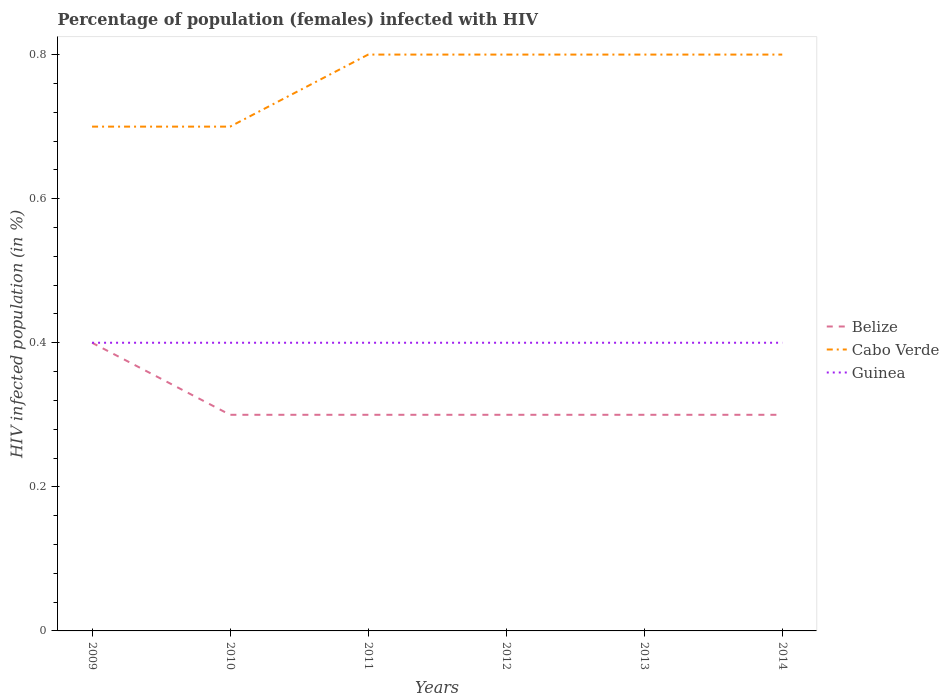Does the line corresponding to Cabo Verde intersect with the line corresponding to Guinea?
Provide a succinct answer. No. Across all years, what is the maximum percentage of HIV infected female population in Guinea?
Offer a terse response. 0.4. In which year was the percentage of HIV infected female population in Cabo Verde maximum?
Offer a very short reply. 2009. What is the difference between the highest and the lowest percentage of HIV infected female population in Guinea?
Provide a short and direct response. 6. What is the difference between two consecutive major ticks on the Y-axis?
Make the answer very short. 0.2. Does the graph contain any zero values?
Provide a short and direct response. No. Where does the legend appear in the graph?
Ensure brevity in your answer.  Center right. How many legend labels are there?
Provide a short and direct response. 3. What is the title of the graph?
Provide a succinct answer. Percentage of population (females) infected with HIV. Does "Benin" appear as one of the legend labels in the graph?
Offer a terse response. No. What is the label or title of the Y-axis?
Make the answer very short. HIV infected population (in %). What is the HIV infected population (in %) of Cabo Verde in 2009?
Give a very brief answer. 0.7. What is the HIV infected population (in %) of Guinea in 2009?
Provide a succinct answer. 0.4. What is the HIV infected population (in %) in Belize in 2010?
Make the answer very short. 0.3. What is the HIV infected population (in %) in Guinea in 2010?
Make the answer very short. 0.4. What is the HIV infected population (in %) in Cabo Verde in 2011?
Provide a short and direct response. 0.8. What is the HIV infected population (in %) of Guinea in 2011?
Offer a very short reply. 0.4. What is the HIV infected population (in %) of Guinea in 2012?
Provide a short and direct response. 0.4. What is the HIV infected population (in %) in Belize in 2013?
Provide a succinct answer. 0.3. What is the HIV infected population (in %) in Cabo Verde in 2013?
Keep it short and to the point. 0.8. Across all years, what is the maximum HIV infected population (in %) of Belize?
Your answer should be compact. 0.4. Across all years, what is the maximum HIV infected population (in %) in Guinea?
Provide a short and direct response. 0.4. Across all years, what is the minimum HIV infected population (in %) of Cabo Verde?
Your response must be concise. 0.7. What is the total HIV infected population (in %) of Belize in the graph?
Offer a terse response. 1.9. What is the total HIV infected population (in %) of Cabo Verde in the graph?
Your response must be concise. 4.6. What is the total HIV infected population (in %) of Guinea in the graph?
Your answer should be very brief. 2.4. What is the difference between the HIV infected population (in %) of Belize in 2009 and that in 2010?
Keep it short and to the point. 0.1. What is the difference between the HIV infected population (in %) of Belize in 2009 and that in 2011?
Your response must be concise. 0.1. What is the difference between the HIV infected population (in %) in Cabo Verde in 2009 and that in 2011?
Give a very brief answer. -0.1. What is the difference between the HIV infected population (in %) of Belize in 2009 and that in 2012?
Offer a terse response. 0.1. What is the difference between the HIV infected population (in %) in Cabo Verde in 2009 and that in 2012?
Provide a succinct answer. -0.1. What is the difference between the HIV infected population (in %) of Guinea in 2009 and that in 2012?
Your answer should be very brief. 0. What is the difference between the HIV infected population (in %) of Cabo Verde in 2009 and that in 2013?
Provide a succinct answer. -0.1. What is the difference between the HIV infected population (in %) of Cabo Verde in 2009 and that in 2014?
Your answer should be very brief. -0.1. What is the difference between the HIV infected population (in %) in Guinea in 2009 and that in 2014?
Offer a very short reply. 0. What is the difference between the HIV infected population (in %) in Cabo Verde in 2010 and that in 2011?
Provide a short and direct response. -0.1. What is the difference between the HIV infected population (in %) in Guinea in 2010 and that in 2011?
Ensure brevity in your answer.  0. What is the difference between the HIV infected population (in %) of Belize in 2010 and that in 2012?
Give a very brief answer. 0. What is the difference between the HIV infected population (in %) in Guinea in 2010 and that in 2012?
Give a very brief answer. 0. What is the difference between the HIV infected population (in %) of Belize in 2010 and that in 2013?
Offer a terse response. 0. What is the difference between the HIV infected population (in %) in Cabo Verde in 2010 and that in 2013?
Offer a very short reply. -0.1. What is the difference between the HIV infected population (in %) of Guinea in 2010 and that in 2013?
Your answer should be very brief. 0. What is the difference between the HIV infected population (in %) in Cabo Verde in 2010 and that in 2014?
Keep it short and to the point. -0.1. What is the difference between the HIV infected population (in %) in Guinea in 2010 and that in 2014?
Give a very brief answer. 0. What is the difference between the HIV infected population (in %) in Belize in 2011 and that in 2012?
Ensure brevity in your answer.  0. What is the difference between the HIV infected population (in %) in Cabo Verde in 2011 and that in 2012?
Offer a very short reply. 0. What is the difference between the HIV infected population (in %) in Guinea in 2011 and that in 2012?
Provide a succinct answer. 0. What is the difference between the HIV infected population (in %) of Guinea in 2011 and that in 2013?
Make the answer very short. 0. What is the difference between the HIV infected population (in %) of Belize in 2011 and that in 2014?
Give a very brief answer. 0. What is the difference between the HIV infected population (in %) of Cabo Verde in 2011 and that in 2014?
Provide a succinct answer. 0. What is the difference between the HIV infected population (in %) of Guinea in 2011 and that in 2014?
Offer a terse response. 0. What is the difference between the HIV infected population (in %) of Belize in 2012 and that in 2013?
Your response must be concise. 0. What is the difference between the HIV infected population (in %) in Cabo Verde in 2012 and that in 2013?
Provide a short and direct response. 0. What is the difference between the HIV infected population (in %) in Guinea in 2012 and that in 2013?
Give a very brief answer. 0. What is the difference between the HIV infected population (in %) of Belize in 2012 and that in 2014?
Ensure brevity in your answer.  0. What is the difference between the HIV infected population (in %) in Cabo Verde in 2013 and that in 2014?
Give a very brief answer. 0. What is the difference between the HIV infected population (in %) of Guinea in 2013 and that in 2014?
Provide a succinct answer. 0. What is the difference between the HIV infected population (in %) of Belize in 2009 and the HIV infected population (in %) of Cabo Verde in 2010?
Your answer should be very brief. -0.3. What is the difference between the HIV infected population (in %) in Belize in 2009 and the HIV infected population (in %) in Guinea in 2010?
Your answer should be compact. 0. What is the difference between the HIV infected population (in %) of Cabo Verde in 2009 and the HIV infected population (in %) of Guinea in 2010?
Provide a short and direct response. 0.3. What is the difference between the HIV infected population (in %) of Belize in 2009 and the HIV infected population (in %) of Cabo Verde in 2011?
Your answer should be very brief. -0.4. What is the difference between the HIV infected population (in %) in Cabo Verde in 2009 and the HIV infected population (in %) in Guinea in 2011?
Offer a very short reply. 0.3. What is the difference between the HIV infected population (in %) in Belize in 2009 and the HIV infected population (in %) in Cabo Verde in 2012?
Offer a terse response. -0.4. What is the difference between the HIV infected population (in %) of Cabo Verde in 2009 and the HIV infected population (in %) of Guinea in 2012?
Offer a terse response. 0.3. What is the difference between the HIV infected population (in %) in Belize in 2009 and the HIV infected population (in %) in Cabo Verde in 2013?
Provide a short and direct response. -0.4. What is the difference between the HIV infected population (in %) of Belize in 2009 and the HIV infected population (in %) of Cabo Verde in 2014?
Give a very brief answer. -0.4. What is the difference between the HIV infected population (in %) in Belize in 2009 and the HIV infected population (in %) in Guinea in 2014?
Your response must be concise. 0. What is the difference between the HIV infected population (in %) of Cabo Verde in 2010 and the HIV infected population (in %) of Guinea in 2011?
Give a very brief answer. 0.3. What is the difference between the HIV infected population (in %) in Belize in 2010 and the HIV infected population (in %) in Guinea in 2012?
Make the answer very short. -0.1. What is the difference between the HIV infected population (in %) of Cabo Verde in 2010 and the HIV infected population (in %) of Guinea in 2012?
Your response must be concise. 0.3. What is the difference between the HIV infected population (in %) in Belize in 2010 and the HIV infected population (in %) in Cabo Verde in 2013?
Offer a terse response. -0.5. What is the difference between the HIV infected population (in %) in Belize in 2010 and the HIV infected population (in %) in Guinea in 2013?
Offer a terse response. -0.1. What is the difference between the HIV infected population (in %) of Belize in 2010 and the HIV infected population (in %) of Guinea in 2014?
Ensure brevity in your answer.  -0.1. What is the difference between the HIV infected population (in %) of Belize in 2011 and the HIV infected population (in %) of Guinea in 2012?
Provide a succinct answer. -0.1. What is the difference between the HIV infected population (in %) of Cabo Verde in 2011 and the HIV infected population (in %) of Guinea in 2012?
Your response must be concise. 0.4. What is the difference between the HIV infected population (in %) of Cabo Verde in 2011 and the HIV infected population (in %) of Guinea in 2013?
Your answer should be very brief. 0.4. What is the difference between the HIV infected population (in %) of Belize in 2011 and the HIV infected population (in %) of Guinea in 2014?
Your response must be concise. -0.1. What is the difference between the HIV infected population (in %) in Belize in 2012 and the HIV infected population (in %) in Guinea in 2013?
Provide a succinct answer. -0.1. What is the difference between the HIV infected population (in %) in Belize in 2012 and the HIV infected population (in %) in Guinea in 2014?
Offer a very short reply. -0.1. What is the difference between the HIV infected population (in %) in Cabo Verde in 2012 and the HIV infected population (in %) in Guinea in 2014?
Make the answer very short. 0.4. What is the difference between the HIV infected population (in %) of Cabo Verde in 2013 and the HIV infected population (in %) of Guinea in 2014?
Your answer should be compact. 0.4. What is the average HIV infected population (in %) of Belize per year?
Your response must be concise. 0.32. What is the average HIV infected population (in %) of Cabo Verde per year?
Provide a short and direct response. 0.77. What is the average HIV infected population (in %) in Guinea per year?
Offer a very short reply. 0.4. In the year 2009, what is the difference between the HIV infected population (in %) of Belize and HIV infected population (in %) of Cabo Verde?
Give a very brief answer. -0.3. In the year 2009, what is the difference between the HIV infected population (in %) in Belize and HIV infected population (in %) in Guinea?
Give a very brief answer. 0. In the year 2009, what is the difference between the HIV infected population (in %) of Cabo Verde and HIV infected population (in %) of Guinea?
Your answer should be very brief. 0.3. In the year 2010, what is the difference between the HIV infected population (in %) of Belize and HIV infected population (in %) of Cabo Verde?
Make the answer very short. -0.4. In the year 2011, what is the difference between the HIV infected population (in %) in Belize and HIV infected population (in %) in Cabo Verde?
Provide a succinct answer. -0.5. In the year 2011, what is the difference between the HIV infected population (in %) of Belize and HIV infected population (in %) of Guinea?
Make the answer very short. -0.1. In the year 2012, what is the difference between the HIV infected population (in %) of Belize and HIV infected population (in %) of Guinea?
Keep it short and to the point. -0.1. In the year 2012, what is the difference between the HIV infected population (in %) in Cabo Verde and HIV infected population (in %) in Guinea?
Give a very brief answer. 0.4. In the year 2013, what is the difference between the HIV infected population (in %) in Belize and HIV infected population (in %) in Guinea?
Keep it short and to the point. -0.1. What is the ratio of the HIV infected population (in %) in Belize in 2009 to that in 2010?
Offer a terse response. 1.33. What is the ratio of the HIV infected population (in %) in Guinea in 2009 to that in 2010?
Make the answer very short. 1. What is the ratio of the HIV infected population (in %) in Cabo Verde in 2009 to that in 2011?
Provide a succinct answer. 0.88. What is the ratio of the HIV infected population (in %) of Guinea in 2009 to that in 2011?
Make the answer very short. 1. What is the ratio of the HIV infected population (in %) of Cabo Verde in 2009 to that in 2012?
Give a very brief answer. 0.88. What is the ratio of the HIV infected population (in %) of Belize in 2009 to that in 2013?
Provide a short and direct response. 1.33. What is the ratio of the HIV infected population (in %) of Cabo Verde in 2009 to that in 2013?
Give a very brief answer. 0.88. What is the ratio of the HIV infected population (in %) in Belize in 2009 to that in 2014?
Keep it short and to the point. 1.33. What is the ratio of the HIV infected population (in %) of Guinea in 2009 to that in 2014?
Offer a terse response. 1. What is the ratio of the HIV infected population (in %) in Belize in 2010 to that in 2011?
Your response must be concise. 1. What is the ratio of the HIV infected population (in %) of Belize in 2010 to that in 2013?
Provide a succinct answer. 1. What is the ratio of the HIV infected population (in %) in Guinea in 2010 to that in 2013?
Offer a very short reply. 1. What is the ratio of the HIV infected population (in %) in Cabo Verde in 2010 to that in 2014?
Provide a short and direct response. 0.88. What is the ratio of the HIV infected population (in %) in Guinea in 2011 to that in 2012?
Make the answer very short. 1. What is the ratio of the HIV infected population (in %) in Belize in 2011 to that in 2013?
Keep it short and to the point. 1. What is the ratio of the HIV infected population (in %) in Cabo Verde in 2011 to that in 2013?
Offer a terse response. 1. What is the ratio of the HIV infected population (in %) of Guinea in 2011 to that in 2014?
Your response must be concise. 1. What is the ratio of the HIV infected population (in %) in Guinea in 2012 to that in 2013?
Provide a short and direct response. 1. What is the ratio of the HIV infected population (in %) of Belize in 2012 to that in 2014?
Ensure brevity in your answer.  1. What is the ratio of the HIV infected population (in %) in Cabo Verde in 2012 to that in 2014?
Make the answer very short. 1. What is the ratio of the HIV infected population (in %) of Belize in 2013 to that in 2014?
Offer a terse response. 1. What is the ratio of the HIV infected population (in %) of Guinea in 2013 to that in 2014?
Make the answer very short. 1. What is the difference between the highest and the second highest HIV infected population (in %) of Belize?
Keep it short and to the point. 0.1. What is the difference between the highest and the second highest HIV infected population (in %) in Guinea?
Provide a succinct answer. 0. What is the difference between the highest and the lowest HIV infected population (in %) in Belize?
Make the answer very short. 0.1. What is the difference between the highest and the lowest HIV infected population (in %) of Guinea?
Your answer should be very brief. 0. 